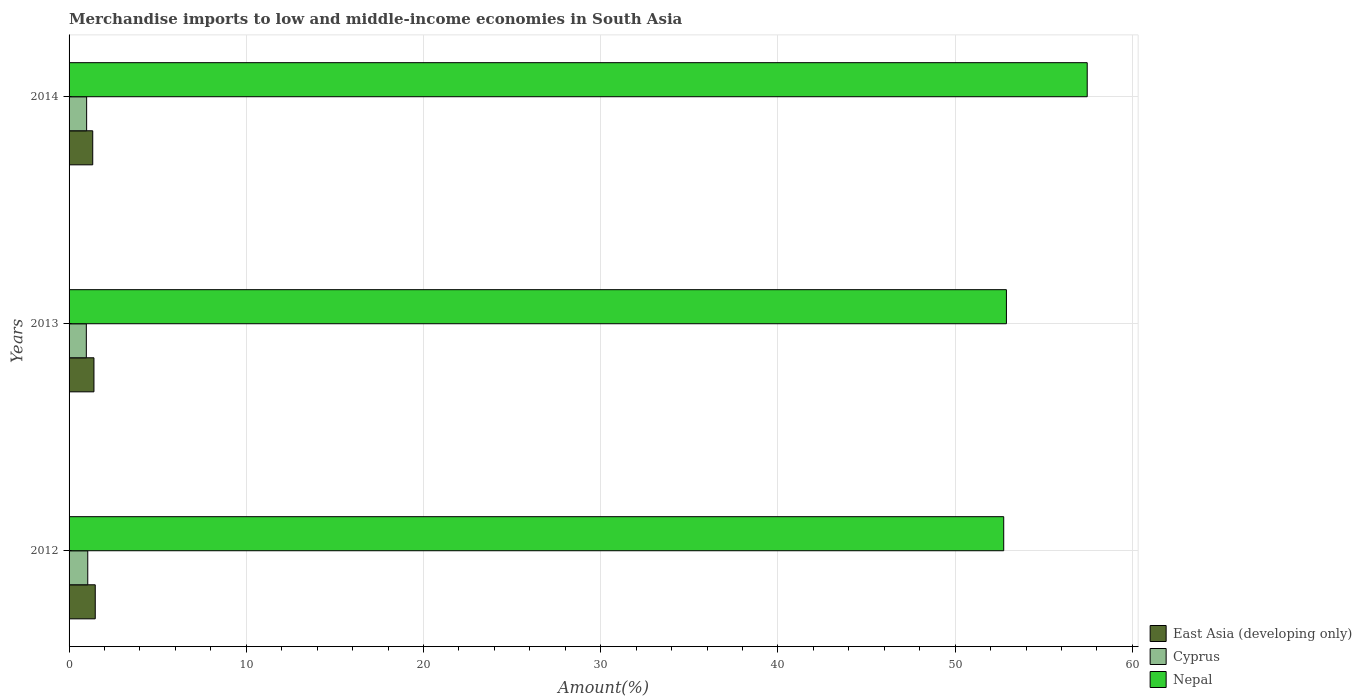How many different coloured bars are there?
Provide a short and direct response. 3. Are the number of bars on each tick of the Y-axis equal?
Offer a terse response. Yes. What is the label of the 3rd group of bars from the top?
Keep it short and to the point. 2012. What is the percentage of amount earned from merchandise imports in Cyprus in 2014?
Your answer should be compact. 0.99. Across all years, what is the maximum percentage of amount earned from merchandise imports in Nepal?
Your answer should be compact. 57.45. Across all years, what is the minimum percentage of amount earned from merchandise imports in East Asia (developing only)?
Provide a short and direct response. 1.34. In which year was the percentage of amount earned from merchandise imports in Nepal maximum?
Your response must be concise. 2014. What is the total percentage of amount earned from merchandise imports in Nepal in the graph?
Offer a very short reply. 163.09. What is the difference between the percentage of amount earned from merchandise imports in Cyprus in 2013 and that in 2014?
Provide a short and direct response. -0.02. What is the difference between the percentage of amount earned from merchandise imports in East Asia (developing only) in 2014 and the percentage of amount earned from merchandise imports in Nepal in 2012?
Your response must be concise. -51.41. What is the average percentage of amount earned from merchandise imports in Nepal per year?
Offer a very short reply. 54.36. In the year 2014, what is the difference between the percentage of amount earned from merchandise imports in Cyprus and percentage of amount earned from merchandise imports in Nepal?
Keep it short and to the point. -56.46. What is the ratio of the percentage of amount earned from merchandise imports in East Asia (developing only) in 2012 to that in 2013?
Make the answer very short. 1.05. Is the percentage of amount earned from merchandise imports in Nepal in 2012 less than that in 2014?
Keep it short and to the point. Yes. What is the difference between the highest and the second highest percentage of amount earned from merchandise imports in Nepal?
Make the answer very short. 4.56. What is the difference between the highest and the lowest percentage of amount earned from merchandise imports in East Asia (developing only)?
Provide a succinct answer. 0.14. In how many years, is the percentage of amount earned from merchandise imports in Nepal greater than the average percentage of amount earned from merchandise imports in Nepal taken over all years?
Keep it short and to the point. 1. Is the sum of the percentage of amount earned from merchandise imports in Cyprus in 2012 and 2013 greater than the maximum percentage of amount earned from merchandise imports in Nepal across all years?
Keep it short and to the point. No. What does the 3rd bar from the top in 2014 represents?
Keep it short and to the point. East Asia (developing only). What does the 3rd bar from the bottom in 2012 represents?
Offer a very short reply. Nepal. How many bars are there?
Keep it short and to the point. 9. What is the difference between two consecutive major ticks on the X-axis?
Offer a very short reply. 10. Are the values on the major ticks of X-axis written in scientific E-notation?
Your answer should be very brief. No. Does the graph contain any zero values?
Your response must be concise. No. Where does the legend appear in the graph?
Provide a succinct answer. Bottom right. How many legend labels are there?
Your answer should be very brief. 3. What is the title of the graph?
Make the answer very short. Merchandise imports to low and middle-income economies in South Asia. Does "Iran" appear as one of the legend labels in the graph?
Offer a very short reply. No. What is the label or title of the X-axis?
Your answer should be very brief. Amount(%). What is the Amount(%) in East Asia (developing only) in 2012?
Your answer should be compact. 1.48. What is the Amount(%) in Cyprus in 2012?
Provide a short and direct response. 1.05. What is the Amount(%) of Nepal in 2012?
Your response must be concise. 52.74. What is the Amount(%) in East Asia (developing only) in 2013?
Provide a short and direct response. 1.4. What is the Amount(%) in Cyprus in 2013?
Offer a terse response. 0.97. What is the Amount(%) of Nepal in 2013?
Offer a very short reply. 52.89. What is the Amount(%) of East Asia (developing only) in 2014?
Make the answer very short. 1.34. What is the Amount(%) of Cyprus in 2014?
Ensure brevity in your answer.  0.99. What is the Amount(%) of Nepal in 2014?
Offer a very short reply. 57.45. Across all years, what is the maximum Amount(%) in East Asia (developing only)?
Offer a terse response. 1.48. Across all years, what is the maximum Amount(%) in Cyprus?
Ensure brevity in your answer.  1.05. Across all years, what is the maximum Amount(%) in Nepal?
Give a very brief answer. 57.45. Across all years, what is the minimum Amount(%) of East Asia (developing only)?
Your answer should be compact. 1.34. Across all years, what is the minimum Amount(%) in Cyprus?
Offer a terse response. 0.97. Across all years, what is the minimum Amount(%) of Nepal?
Offer a terse response. 52.74. What is the total Amount(%) in East Asia (developing only) in the graph?
Ensure brevity in your answer.  4.22. What is the total Amount(%) of Cyprus in the graph?
Give a very brief answer. 3.02. What is the total Amount(%) of Nepal in the graph?
Keep it short and to the point. 163.09. What is the difference between the Amount(%) of East Asia (developing only) in 2012 and that in 2013?
Your answer should be compact. 0.07. What is the difference between the Amount(%) of Cyprus in 2012 and that in 2013?
Give a very brief answer. 0.08. What is the difference between the Amount(%) of Nepal in 2012 and that in 2013?
Provide a succinct answer. -0.15. What is the difference between the Amount(%) of East Asia (developing only) in 2012 and that in 2014?
Give a very brief answer. 0.14. What is the difference between the Amount(%) of Cyprus in 2012 and that in 2014?
Provide a short and direct response. 0.06. What is the difference between the Amount(%) of Nepal in 2012 and that in 2014?
Keep it short and to the point. -4.71. What is the difference between the Amount(%) of East Asia (developing only) in 2013 and that in 2014?
Make the answer very short. 0.07. What is the difference between the Amount(%) of Cyprus in 2013 and that in 2014?
Your response must be concise. -0.02. What is the difference between the Amount(%) of Nepal in 2013 and that in 2014?
Your answer should be very brief. -4.56. What is the difference between the Amount(%) in East Asia (developing only) in 2012 and the Amount(%) in Cyprus in 2013?
Provide a short and direct response. 0.5. What is the difference between the Amount(%) of East Asia (developing only) in 2012 and the Amount(%) of Nepal in 2013?
Give a very brief answer. -51.42. What is the difference between the Amount(%) of Cyprus in 2012 and the Amount(%) of Nepal in 2013?
Offer a terse response. -51.84. What is the difference between the Amount(%) of East Asia (developing only) in 2012 and the Amount(%) of Cyprus in 2014?
Your response must be concise. 0.49. What is the difference between the Amount(%) in East Asia (developing only) in 2012 and the Amount(%) in Nepal in 2014?
Your response must be concise. -55.98. What is the difference between the Amount(%) of Cyprus in 2012 and the Amount(%) of Nepal in 2014?
Make the answer very short. -56.4. What is the difference between the Amount(%) of East Asia (developing only) in 2013 and the Amount(%) of Cyprus in 2014?
Make the answer very short. 0.41. What is the difference between the Amount(%) in East Asia (developing only) in 2013 and the Amount(%) in Nepal in 2014?
Provide a succinct answer. -56.05. What is the difference between the Amount(%) of Cyprus in 2013 and the Amount(%) of Nepal in 2014?
Offer a terse response. -56.48. What is the average Amount(%) in East Asia (developing only) per year?
Give a very brief answer. 1.41. What is the average Amount(%) of Cyprus per year?
Offer a very short reply. 1.01. What is the average Amount(%) of Nepal per year?
Your answer should be very brief. 54.36. In the year 2012, what is the difference between the Amount(%) of East Asia (developing only) and Amount(%) of Cyprus?
Give a very brief answer. 0.42. In the year 2012, what is the difference between the Amount(%) in East Asia (developing only) and Amount(%) in Nepal?
Make the answer very short. -51.26. In the year 2012, what is the difference between the Amount(%) in Cyprus and Amount(%) in Nepal?
Provide a short and direct response. -51.69. In the year 2013, what is the difference between the Amount(%) of East Asia (developing only) and Amount(%) of Cyprus?
Give a very brief answer. 0.43. In the year 2013, what is the difference between the Amount(%) in East Asia (developing only) and Amount(%) in Nepal?
Keep it short and to the point. -51.49. In the year 2013, what is the difference between the Amount(%) of Cyprus and Amount(%) of Nepal?
Your response must be concise. -51.92. In the year 2014, what is the difference between the Amount(%) of East Asia (developing only) and Amount(%) of Cyprus?
Give a very brief answer. 0.34. In the year 2014, what is the difference between the Amount(%) in East Asia (developing only) and Amount(%) in Nepal?
Provide a succinct answer. -56.12. In the year 2014, what is the difference between the Amount(%) of Cyprus and Amount(%) of Nepal?
Offer a terse response. -56.46. What is the ratio of the Amount(%) in East Asia (developing only) in 2012 to that in 2013?
Keep it short and to the point. 1.05. What is the ratio of the Amount(%) in Cyprus in 2012 to that in 2013?
Offer a terse response. 1.08. What is the ratio of the Amount(%) in East Asia (developing only) in 2012 to that in 2014?
Provide a short and direct response. 1.11. What is the ratio of the Amount(%) in Cyprus in 2012 to that in 2014?
Provide a succinct answer. 1.06. What is the ratio of the Amount(%) in Nepal in 2012 to that in 2014?
Keep it short and to the point. 0.92. What is the ratio of the Amount(%) in East Asia (developing only) in 2013 to that in 2014?
Your answer should be very brief. 1.05. What is the ratio of the Amount(%) of Cyprus in 2013 to that in 2014?
Ensure brevity in your answer.  0.98. What is the ratio of the Amount(%) of Nepal in 2013 to that in 2014?
Your answer should be very brief. 0.92. What is the difference between the highest and the second highest Amount(%) of East Asia (developing only)?
Your response must be concise. 0.07. What is the difference between the highest and the second highest Amount(%) in Cyprus?
Offer a very short reply. 0.06. What is the difference between the highest and the second highest Amount(%) of Nepal?
Your response must be concise. 4.56. What is the difference between the highest and the lowest Amount(%) of East Asia (developing only)?
Your response must be concise. 0.14. What is the difference between the highest and the lowest Amount(%) in Cyprus?
Offer a terse response. 0.08. What is the difference between the highest and the lowest Amount(%) in Nepal?
Your answer should be compact. 4.71. 